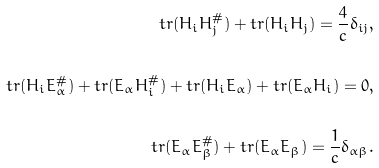Convert formula to latex. <formula><loc_0><loc_0><loc_500><loc_500>t r ( H _ { i } H _ { j } ^ { \# } ) + t r ( H _ { i } H _ { j } ) = \frac { 4 } { c } \delta _ { i j } , \\ \\ t r ( H _ { i } E _ { \alpha } ^ { \# } ) + t r ( E _ { \alpha } H _ { i } ^ { \# } ) + t r ( H _ { i } E _ { \alpha } ) + t r ( E _ { \alpha } H _ { i } ) = 0 , \\ \\ t r ( E _ { \alpha } E _ { \beta } ^ { \# } ) + t r ( E _ { \alpha } E _ { \beta } ) = \frac { 1 } { c } \delta _ { \alpha \beta } .</formula> 